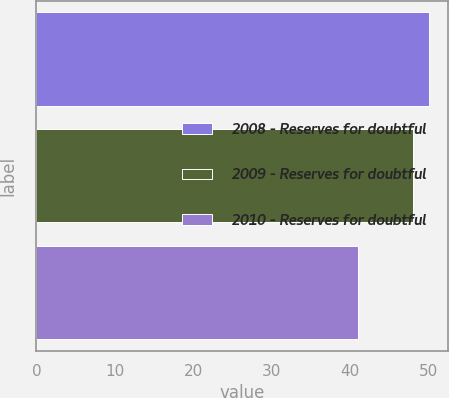Convert chart. <chart><loc_0><loc_0><loc_500><loc_500><bar_chart><fcel>2008 - Reserves for doubtful<fcel>2009 - Reserves for doubtful<fcel>2010 - Reserves for doubtful<nl><fcel>50<fcel>48<fcel>41<nl></chart> 